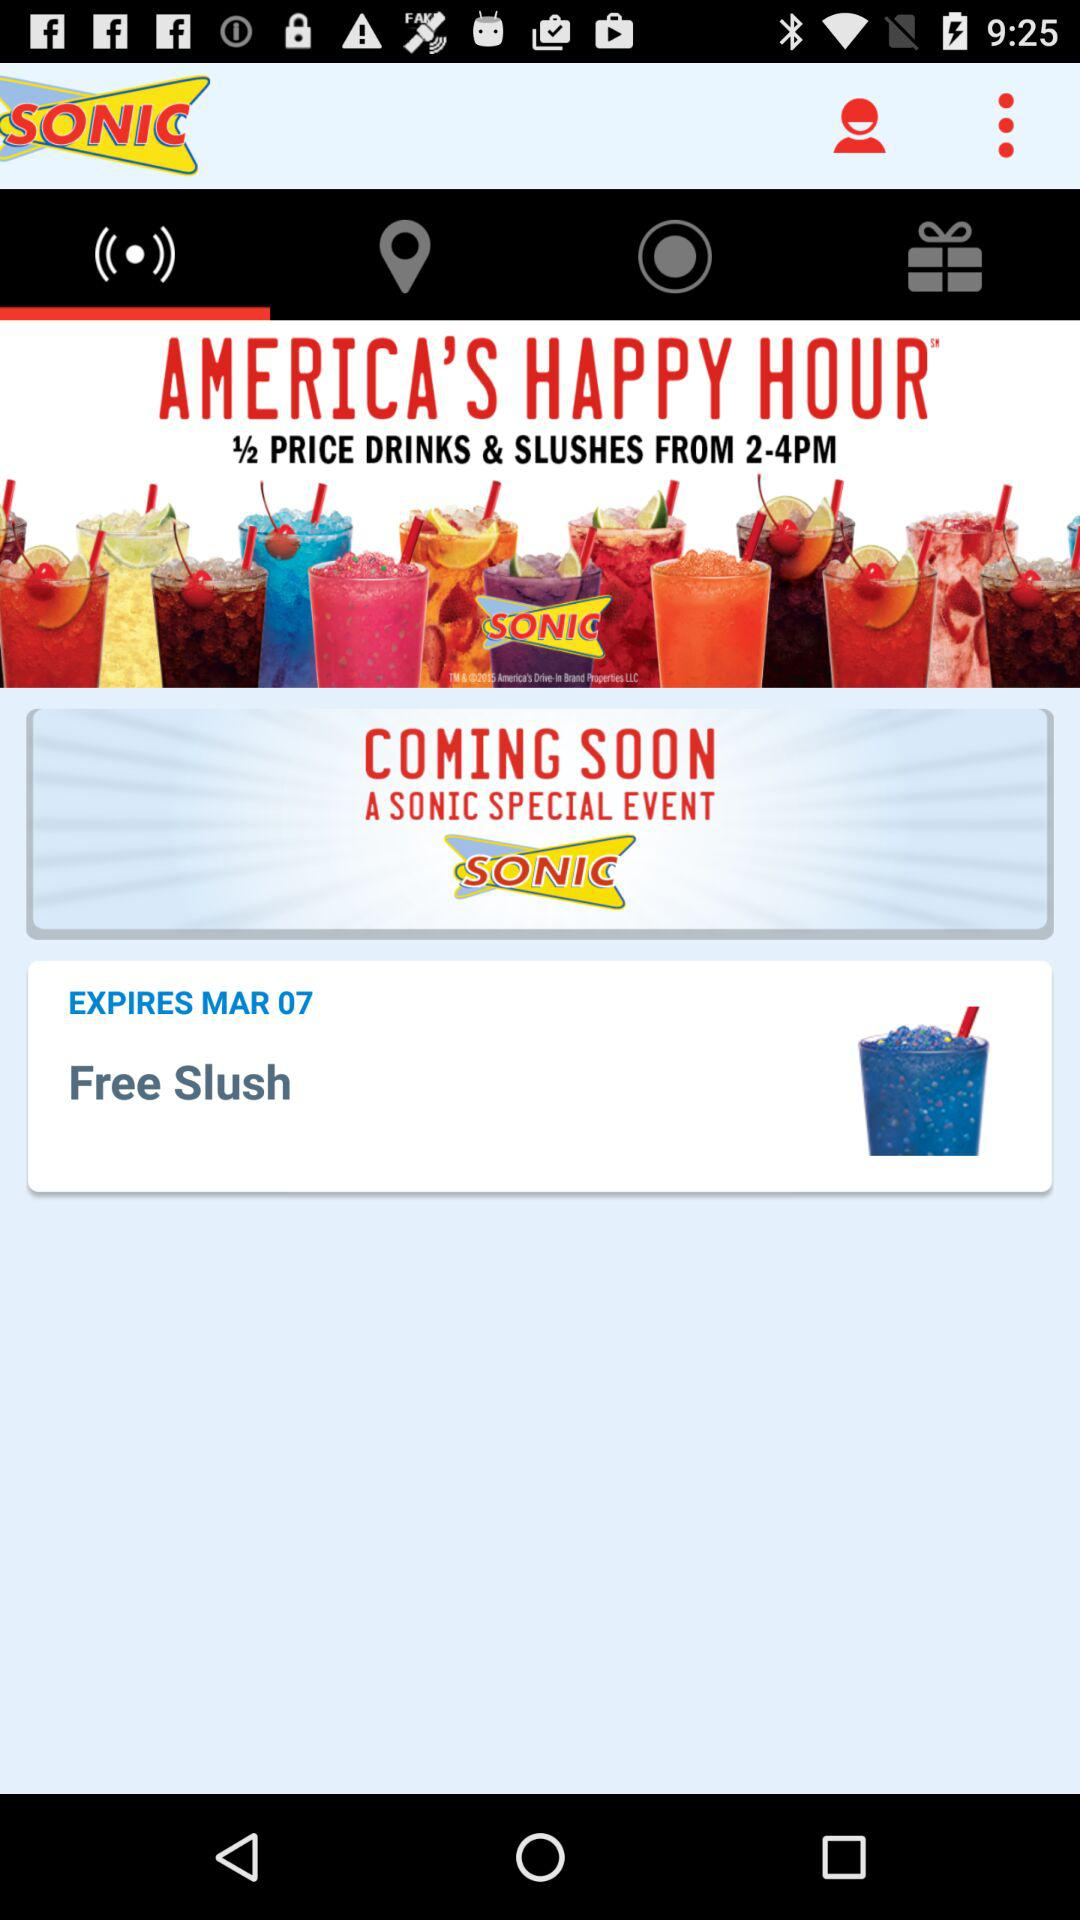Where is the Sonic's location?
When the provided information is insufficient, respond with <no answer>. <no answer> 